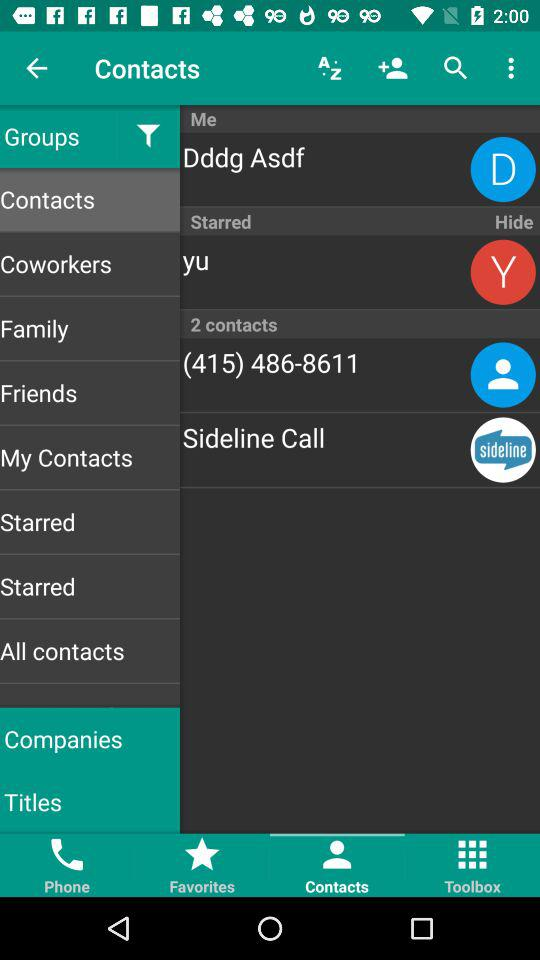What is the contact number? The contact number is (415) 486-8611. 